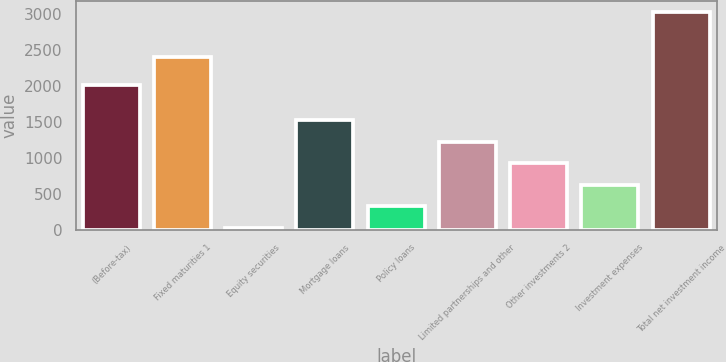Convert chart. <chart><loc_0><loc_0><loc_500><loc_500><bar_chart><fcel>(Before-tax)<fcel>Fixed maturities 1<fcel>Equity securities<fcel>Mortgage loans<fcel>Policy loans<fcel>Limited partnerships and other<fcel>Other investments 2<fcel>Investment expenses<fcel>Total net investment income<nl><fcel>2015<fcel>2409<fcel>25<fcel>1527.5<fcel>325.5<fcel>1227<fcel>926.5<fcel>626<fcel>3030<nl></chart> 